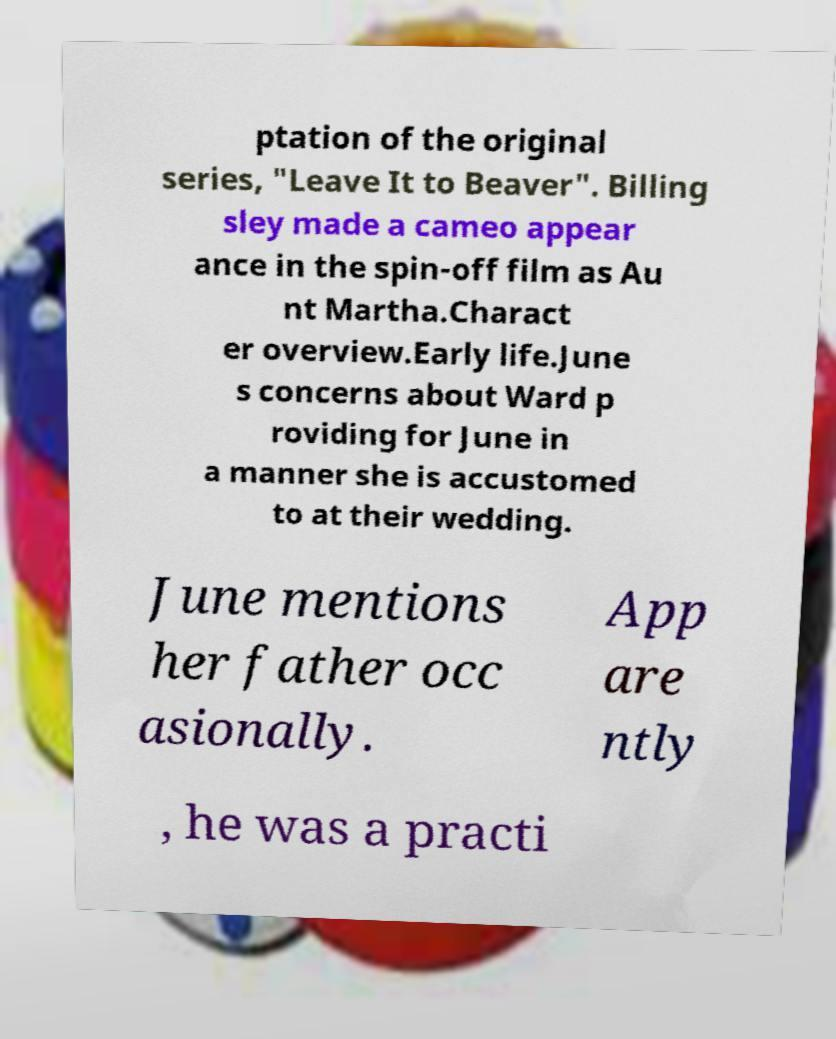For documentation purposes, I need the text within this image transcribed. Could you provide that? ptation of the original series, "Leave It to Beaver". Billing sley made a cameo appear ance in the spin-off film as Au nt Martha.Charact er overview.Early life.June s concerns about Ward p roviding for June in a manner she is accustomed to at their wedding. June mentions her father occ asionally. App are ntly , he was a practi 